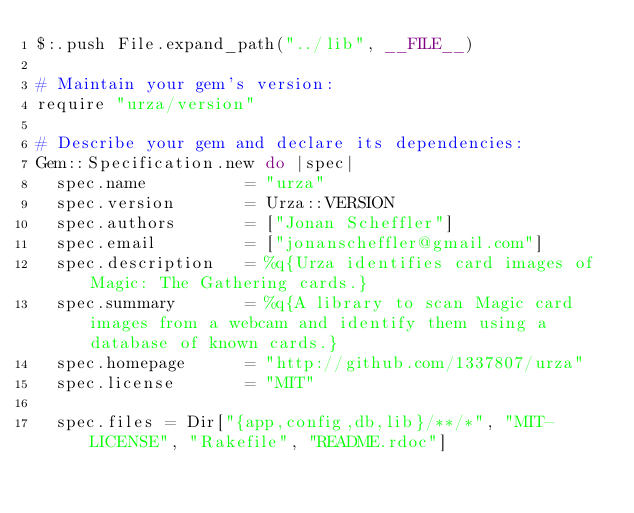<code> <loc_0><loc_0><loc_500><loc_500><_Ruby_>$:.push File.expand_path("../lib", __FILE__)

# Maintain your gem's version:
require "urza/version"

# Describe your gem and declare its dependencies:
Gem::Specification.new do |spec|
  spec.name          = "urza"
  spec.version       = Urza::VERSION
  spec.authors       = ["Jonan Scheffler"]
  spec.email         = ["jonanscheffler@gmail.com"]
  spec.description   = %q{Urza identifies card images of Magic: The Gathering cards.}
  spec.summary       = %q{A library to scan Magic card images from a webcam and identify them using a database of known cards.}
  spec.homepage      = "http://github.com/1337807/urza"
  spec.license       = "MIT"

  spec.files = Dir["{app,config,db,lib}/**/*", "MIT-LICENSE", "Rakefile", "README.rdoc"]</code> 